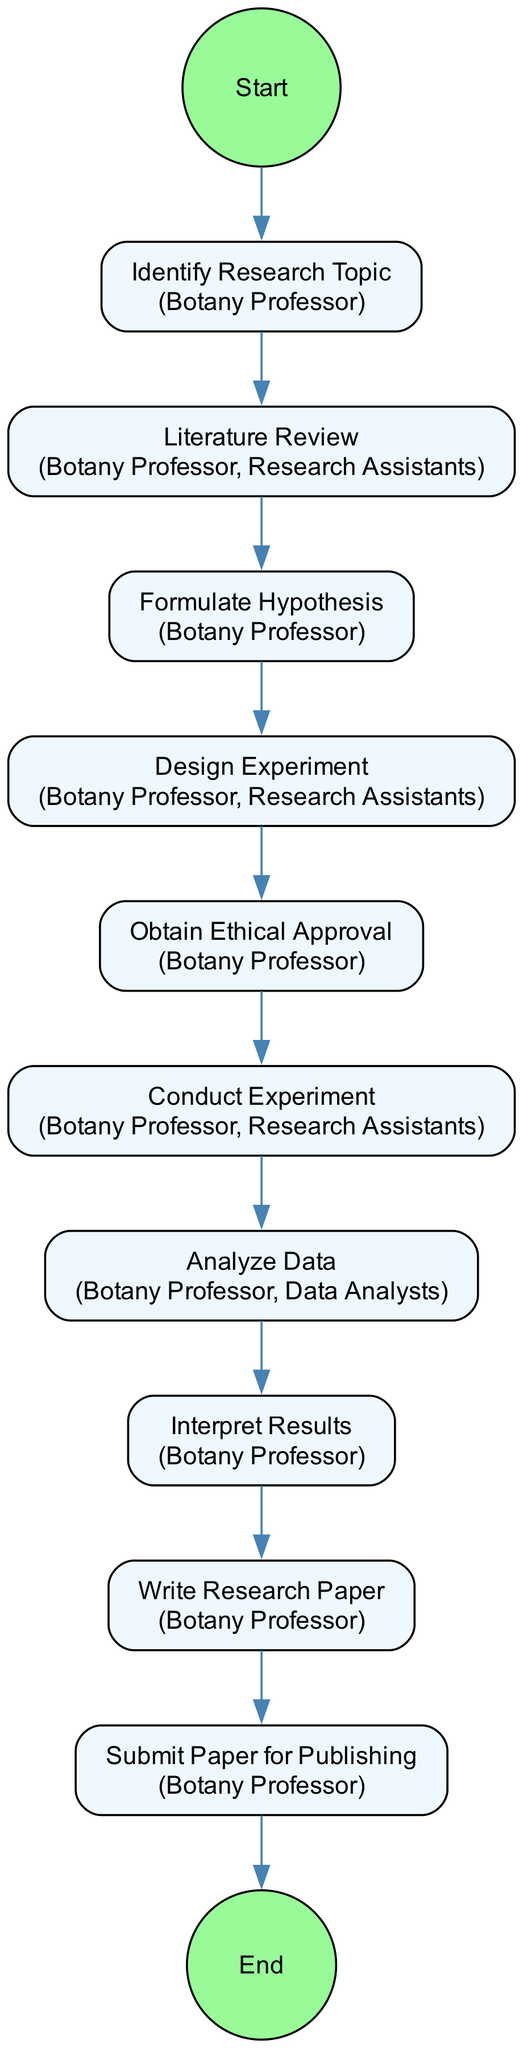What is the first activity listed in the diagram? The first activity listed is "Identify Research Topic." This can be determined by looking at the first node in the sequence of activities.
Answer: Identify Research Topic How many participants are involved in the "Conduct Experiment" activity? The "Conduct Experiment" activity has two participants mentioned: the Botany Professor and Research Assistants. Therefore, by examining the node, we find the participants listed.
Answer: Two What activity follows "Literature Review"? The activity that follows "Literature Review" is "Formulate Hypothesis." This is inferred from the direct arrow leading from "Literature Review" to "Formulate Hypothesis."
Answer: Formulate Hypothesis Which activity involves "Data Analysts"? The activity that involves "Data Analysts" is "Analyze Data." This can be identified by checking the participant list for the corresponding node in the diagram.
Answer: Analyze Data What is the last step before submitting the research paper? The last step before submitting the research paper is "Write Research Paper." This is identified by following the arrows leading to the final activity in the sequence.
Answer: Write Research Paper How many activities are there in total in this diagram? There are ten activities in total within the diagram. This can be counted by looking at the individual nodes representing each activity.
Answer: Ten Which activity is solely conducted by the Botany Professor? The activity that is solely conducted by the Botany Professor is "Interpret Results." This can be determined by checking the participant list for that specific node and noting that no other participants are mentioned.
Answer: Interpret Results What comes immediately after "Obtain Ethical Approval"? "Conduct Experiment" comes immediately after "Obtain Ethical Approval." This is derived from the connectivity of the nodes, where an arrow points from "Obtain Ethical Approval" to "Conduct Experiment."
Answer: Conduct Experiment What is the primary action of the "Write Research Paper" activity? The primary action of the "Write Research Paper" activity is to document the research process, data analysis, and conclusions. This is detailed in the description associated with this particular activity in the diagram.
Answer: Document the research process Which two activities involve Research Assistants? The two activities that involve Research Assistants are "Literature Review" and "Design Experiment." Both activities have Research Assistants listed as participants in their respective nodes.
Answer: Literature Review, Design Experiment 